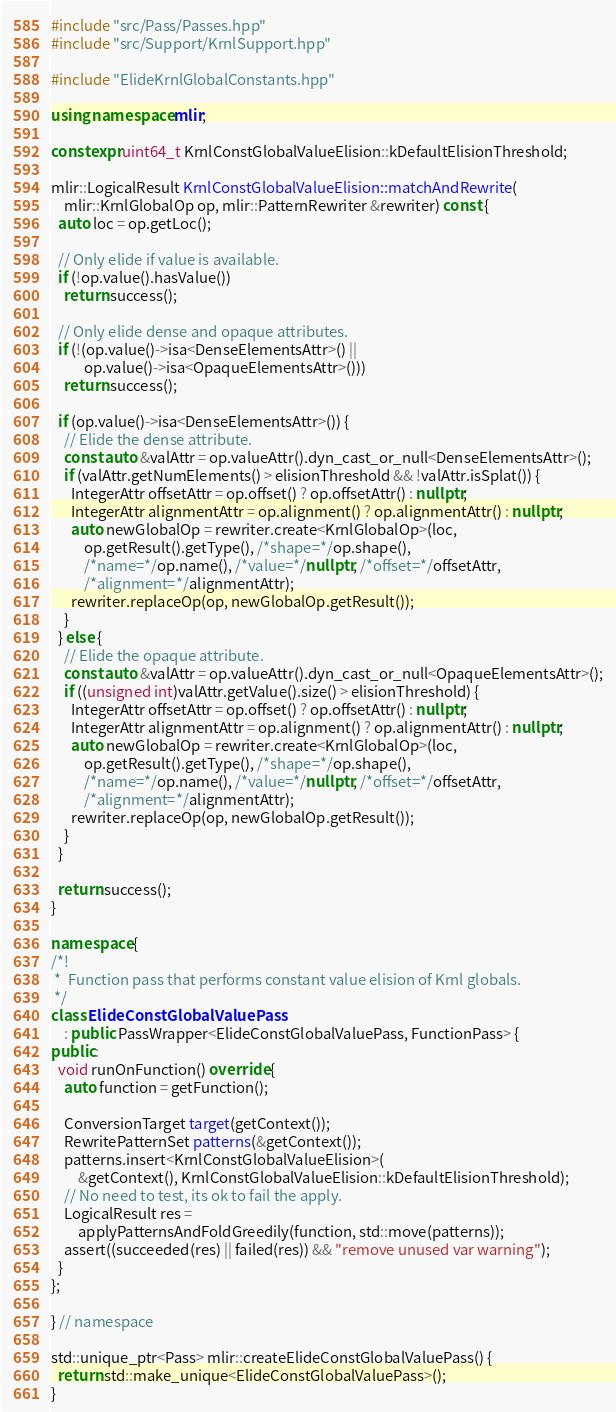<code> <loc_0><loc_0><loc_500><loc_500><_C++_>#include "src/Pass/Passes.hpp"
#include "src/Support/KrnlSupport.hpp"

#include "ElideKrnlGlobalConstants.hpp"

using namespace mlir;

constexpr uint64_t KrnlConstGlobalValueElision::kDefaultElisionThreshold;

mlir::LogicalResult KrnlConstGlobalValueElision::matchAndRewrite(
    mlir::KrnlGlobalOp op, mlir::PatternRewriter &rewriter) const {
  auto loc = op.getLoc();

  // Only elide if value is available.
  if (!op.value().hasValue())
    return success();

  // Only elide dense and opaque attributes.
  if (!(op.value()->isa<DenseElementsAttr>() ||
          op.value()->isa<OpaqueElementsAttr>()))
    return success();

  if (op.value()->isa<DenseElementsAttr>()) {
    // Elide the dense attribute.
    const auto &valAttr = op.valueAttr().dyn_cast_or_null<DenseElementsAttr>();
    if (valAttr.getNumElements() > elisionThreshold && !valAttr.isSplat()) {
      IntegerAttr offsetAttr = op.offset() ? op.offsetAttr() : nullptr;
      IntegerAttr alignmentAttr = op.alignment() ? op.alignmentAttr() : nullptr;
      auto newGlobalOp = rewriter.create<KrnlGlobalOp>(loc,
          op.getResult().getType(), /*shape=*/op.shape(),
          /*name=*/op.name(), /*value=*/nullptr, /*offset=*/offsetAttr,
          /*alignment=*/alignmentAttr);
      rewriter.replaceOp(op, newGlobalOp.getResult());
    }
  } else {
    // Elide the opaque attribute.
    const auto &valAttr = op.valueAttr().dyn_cast_or_null<OpaqueElementsAttr>();
    if ((unsigned int)valAttr.getValue().size() > elisionThreshold) {
      IntegerAttr offsetAttr = op.offset() ? op.offsetAttr() : nullptr;
      IntegerAttr alignmentAttr = op.alignment() ? op.alignmentAttr() : nullptr;
      auto newGlobalOp = rewriter.create<KrnlGlobalOp>(loc,
          op.getResult().getType(), /*shape=*/op.shape(),
          /*name=*/op.name(), /*value=*/nullptr, /*offset=*/offsetAttr,
          /*alignment=*/alignmentAttr);
      rewriter.replaceOp(op, newGlobalOp.getResult());
    }
  }

  return success();
}

namespace {
/*!
 *  Function pass that performs constant value elision of Krnl globals.
 */
class ElideConstGlobalValuePass
    : public PassWrapper<ElideConstGlobalValuePass, FunctionPass> {
public:
  void runOnFunction() override {
    auto function = getFunction();

    ConversionTarget target(getContext());
    RewritePatternSet patterns(&getContext());
    patterns.insert<KrnlConstGlobalValueElision>(
        &getContext(), KrnlConstGlobalValueElision::kDefaultElisionThreshold);
    // No need to test, its ok to fail the apply.
    LogicalResult res =
        applyPatternsAndFoldGreedily(function, std::move(patterns));
    assert((succeeded(res) || failed(res)) && "remove unused var warning");
  }
};

} // namespace

std::unique_ptr<Pass> mlir::createElideConstGlobalValuePass() {
  return std::make_unique<ElideConstGlobalValuePass>();
}
</code> 